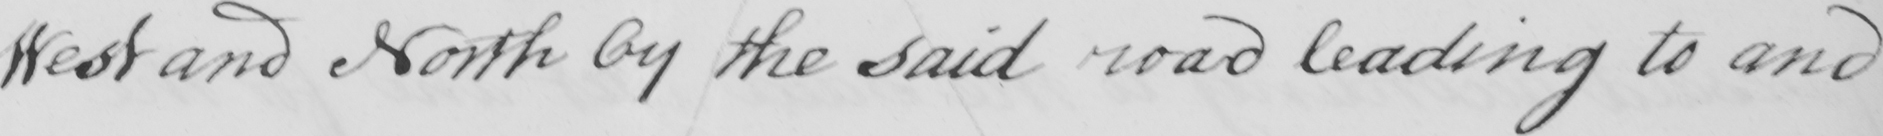Can you read and transcribe this handwriting? West and North by the said road leading to and 